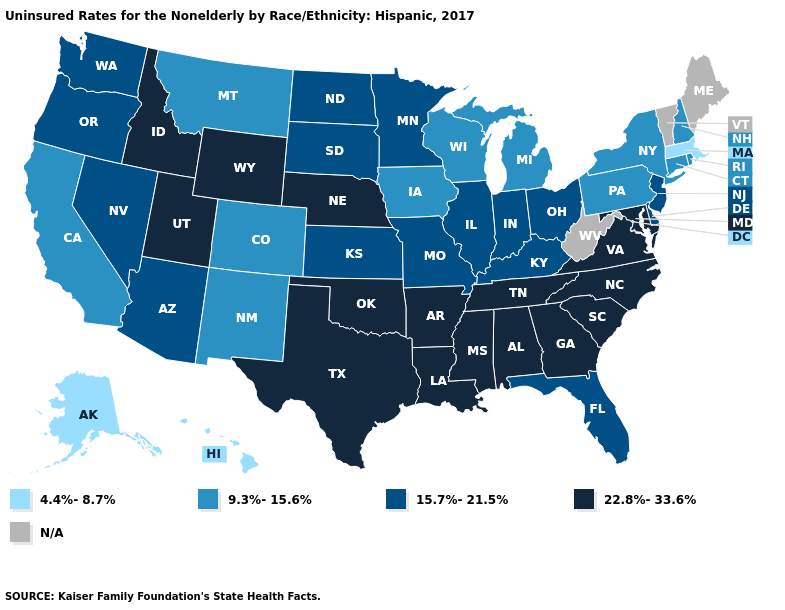What is the lowest value in the USA?
Answer briefly. 4.4%-8.7%. Does the first symbol in the legend represent the smallest category?
Give a very brief answer. Yes. Does Utah have the highest value in the West?
Short answer required. Yes. Name the states that have a value in the range 4.4%-8.7%?
Write a very short answer. Alaska, Hawaii, Massachusetts. Does Utah have the highest value in the USA?
Give a very brief answer. Yes. Name the states that have a value in the range 9.3%-15.6%?
Keep it brief. California, Colorado, Connecticut, Iowa, Michigan, Montana, New Hampshire, New Mexico, New York, Pennsylvania, Rhode Island, Wisconsin. Name the states that have a value in the range 9.3%-15.6%?
Quick response, please. California, Colorado, Connecticut, Iowa, Michigan, Montana, New Hampshire, New Mexico, New York, Pennsylvania, Rhode Island, Wisconsin. Name the states that have a value in the range 15.7%-21.5%?
Answer briefly. Arizona, Delaware, Florida, Illinois, Indiana, Kansas, Kentucky, Minnesota, Missouri, Nevada, New Jersey, North Dakota, Ohio, Oregon, South Dakota, Washington. How many symbols are there in the legend?
Answer briefly. 5. Does Wyoming have the highest value in the West?
Keep it brief. Yes. What is the lowest value in states that border Utah?
Quick response, please. 9.3%-15.6%. What is the value of New Jersey?
Answer briefly. 15.7%-21.5%. Name the states that have a value in the range 9.3%-15.6%?
Quick response, please. California, Colorado, Connecticut, Iowa, Michigan, Montana, New Hampshire, New Mexico, New York, Pennsylvania, Rhode Island, Wisconsin. Which states hav the highest value in the South?
Keep it brief. Alabama, Arkansas, Georgia, Louisiana, Maryland, Mississippi, North Carolina, Oklahoma, South Carolina, Tennessee, Texas, Virginia. 